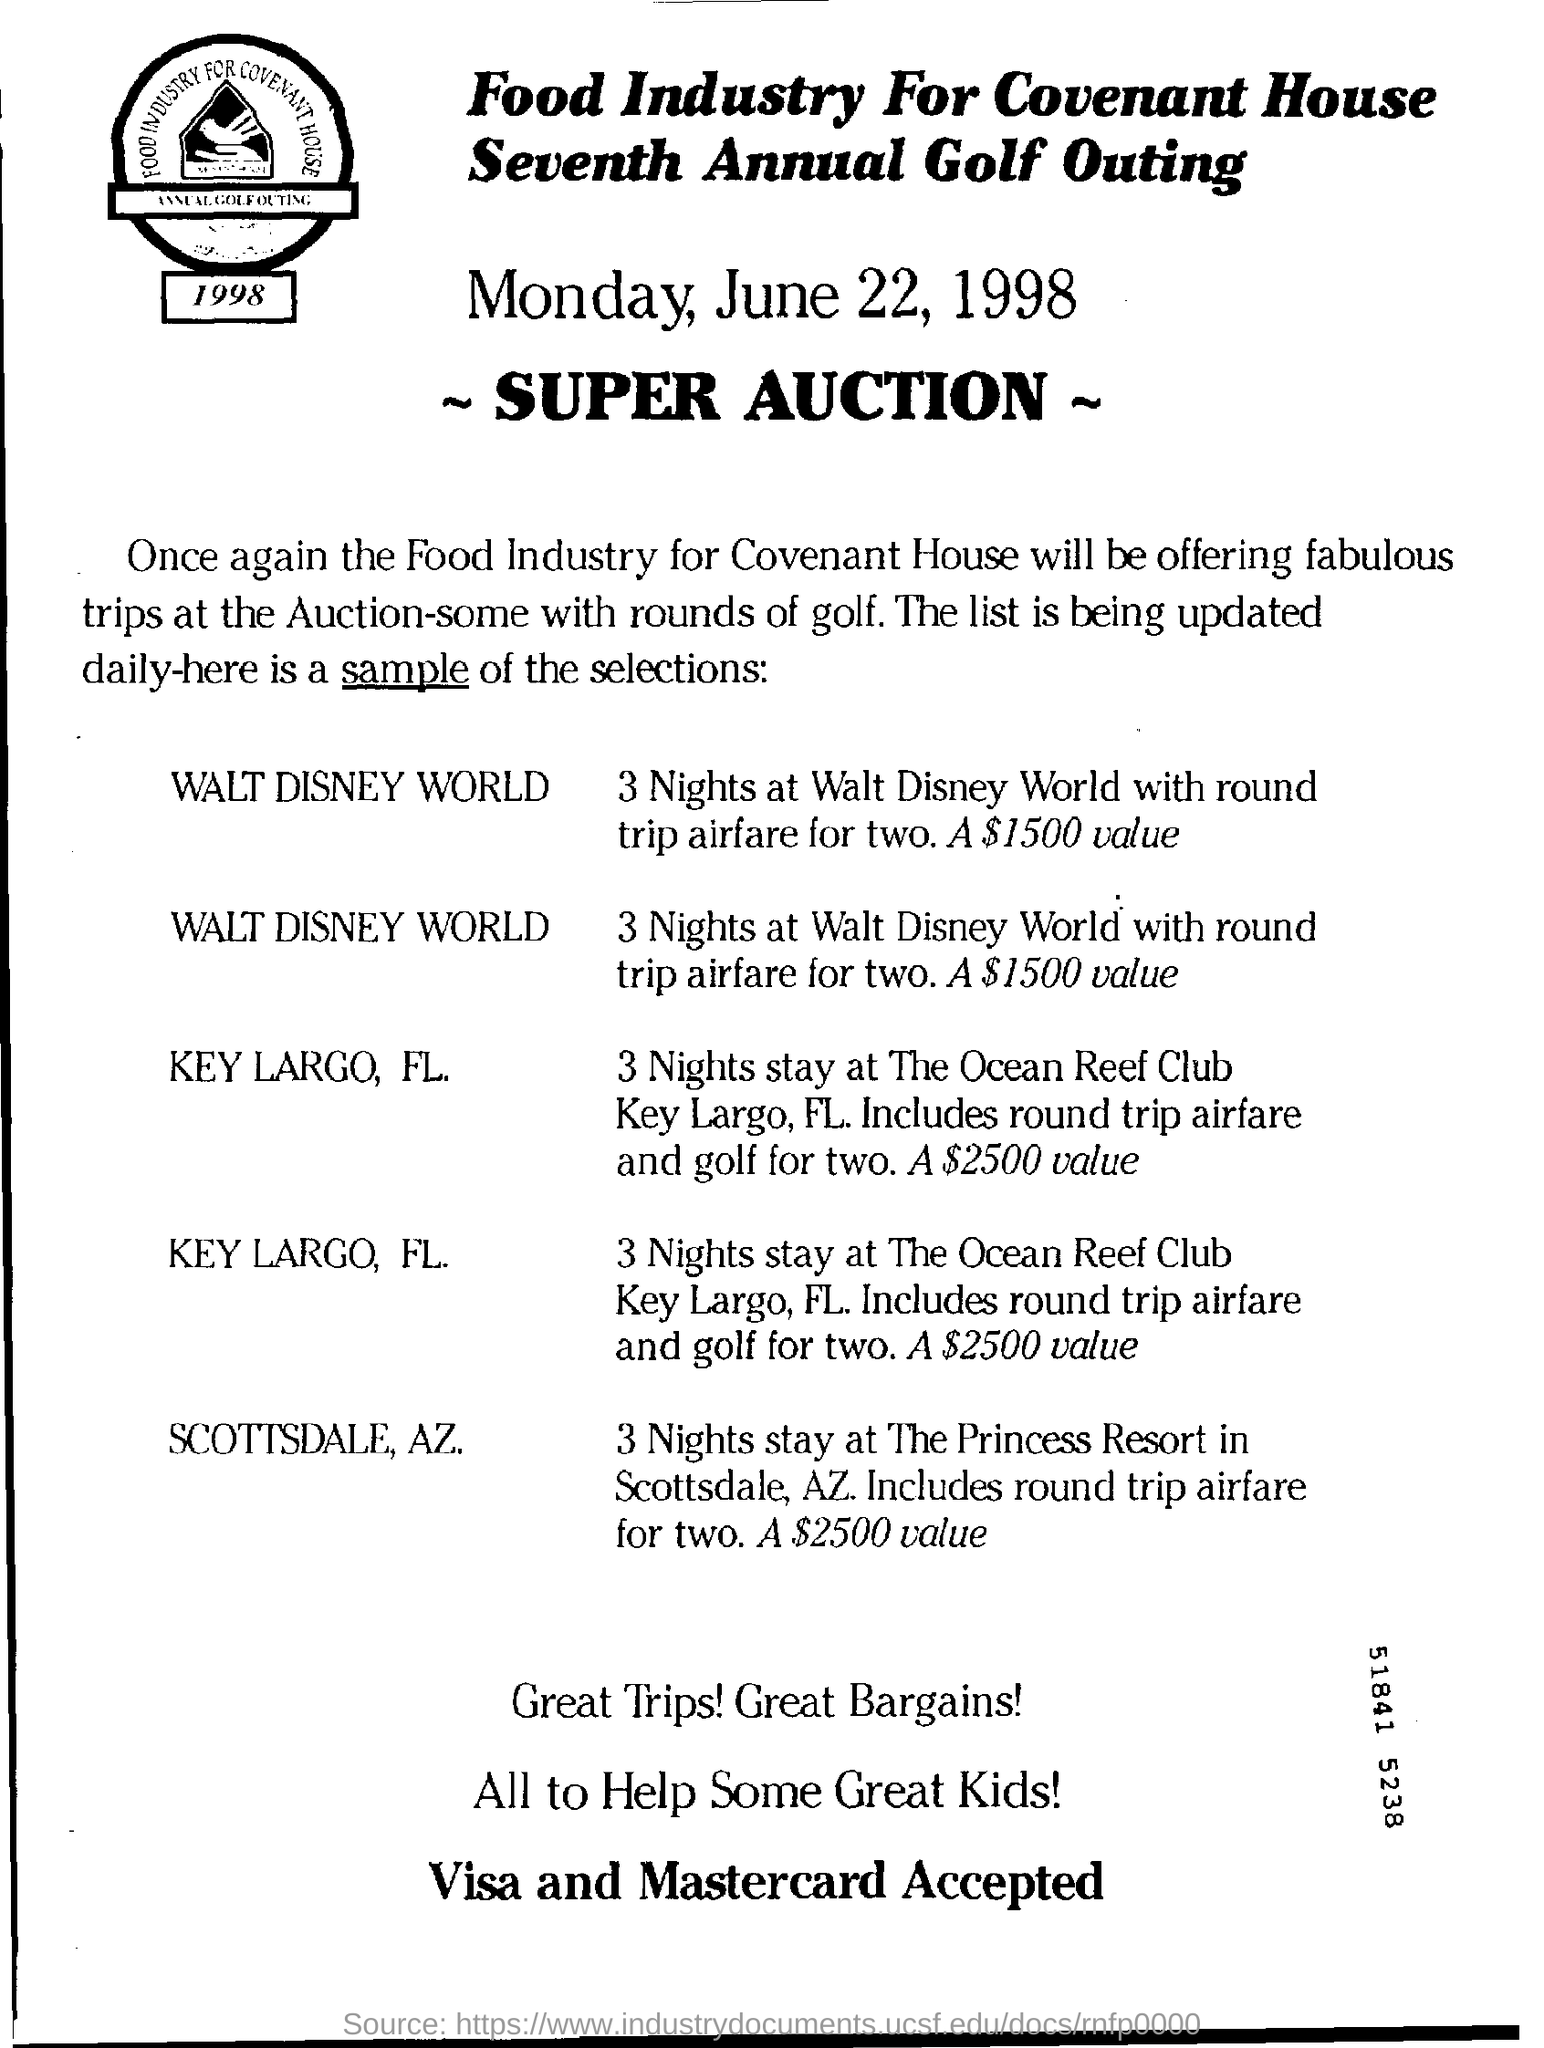Outline some significant characteristics in this image. The Seventh Annual Golf Outing is being organized by the Food Industry for Covenant House. The super auction is scheduled to take place on Monday, June 22, 1998. The cost for a 3-night trip to Walt Disney World, including round trip airfare for two people, is approximately $1,500. 